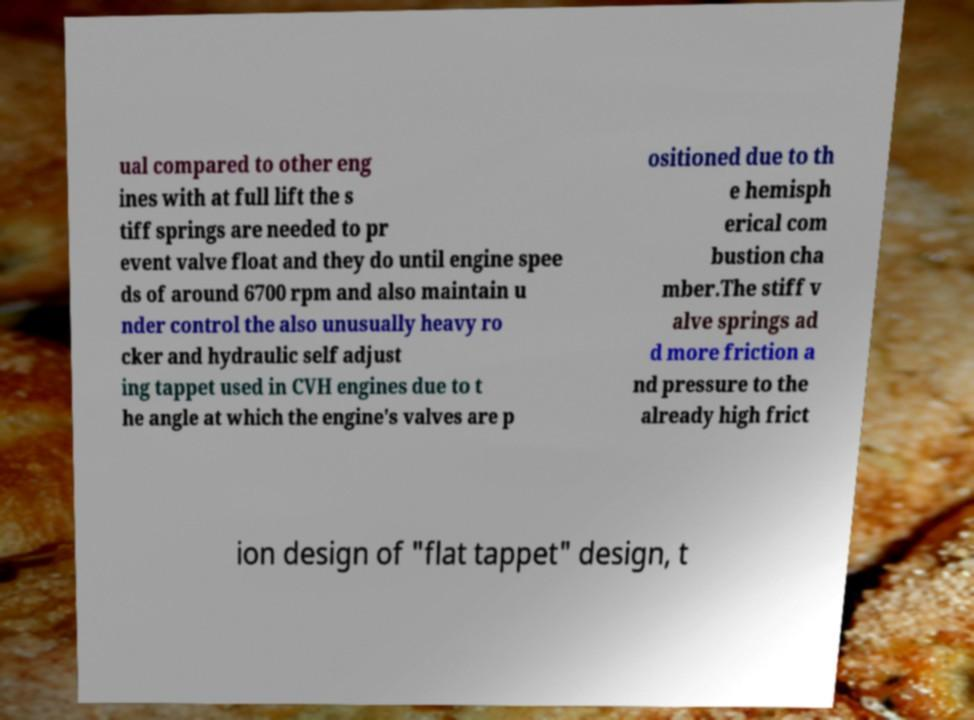Could you assist in decoding the text presented in this image and type it out clearly? ual compared to other eng ines with at full lift the s tiff springs are needed to pr event valve float and they do until engine spee ds of around 6700 rpm and also maintain u nder control the also unusually heavy ro cker and hydraulic self adjust ing tappet used in CVH engines due to t he angle at which the engine's valves are p ositioned due to th e hemisph erical com bustion cha mber.The stiff v alve springs ad d more friction a nd pressure to the already high frict ion design of "flat tappet" design, t 